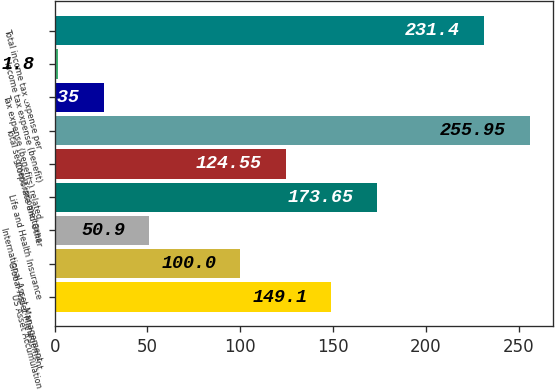Convert chart. <chart><loc_0><loc_0><loc_500><loc_500><bar_chart><fcel>US Asset Accumulation<fcel>Global Asset Management<fcel>International Asset Management<fcel>Life and Health Insurance<fcel>Corporate and Other<fcel>Total segment income taxes<fcel>Tax expense (benefits) related<fcel>Income tax expense (benefit)<fcel>Total income tax expense per<nl><fcel>149.1<fcel>100<fcel>50.9<fcel>173.65<fcel>124.55<fcel>255.95<fcel>26.35<fcel>1.8<fcel>231.4<nl></chart> 